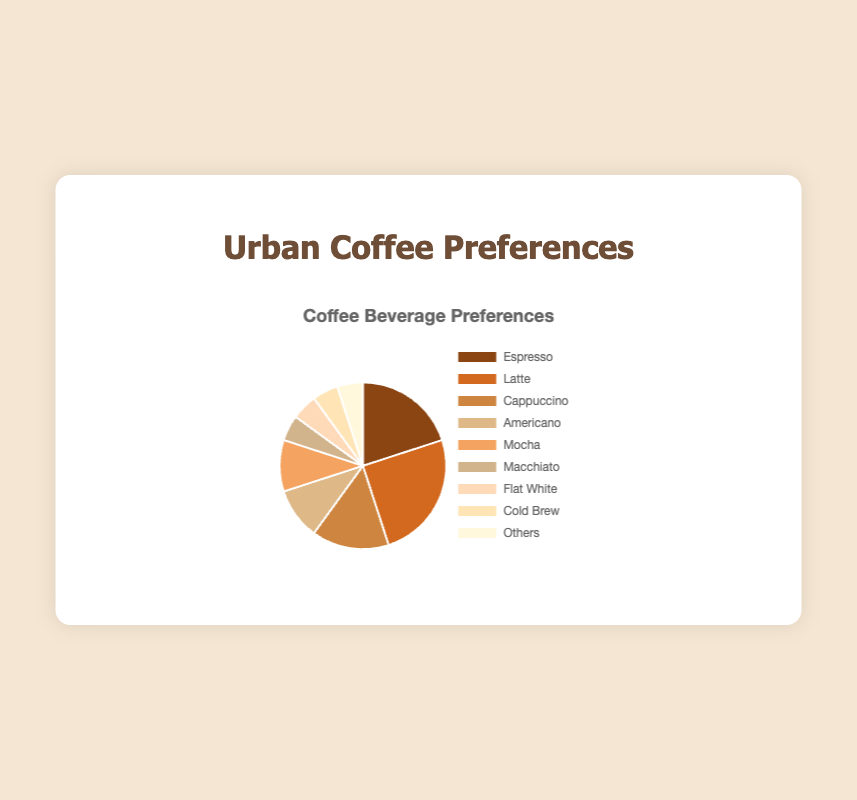1. What coffee beverage has the highest preference among urban consumers? To determine the coffee beverage with the highest preference, look for the slice of the pie chart with the largest percentage. The beverage with a 25% share is the one.
Answer: Latte 2. Which two coffee types have the same percentage preference? Look at the pie chart and identify the coffee types that have equal-sized sections representing the same percentage. Both Americano and Mocha have 10%
Answer: Americano and Mocha 3. What is the total percentage of consumers preferring Americano, Mocha, and Macchiato? Add the percentages of Americano (10%), Mocha (10%), and Macchiato (5%) to get the total. 10% + 10% + 5% = 25%
Answer: 25% 4. Which coffee type has a higher preference: Espresso or Cappuccino? Compare the percentage slices for Espresso (20%) and Cappuccino (15%) in the pie chart. Espresso has a higher percentage.
Answer: Espresso 5. How much more popular is Latte compared to Flat White? Find the percentage difference by subtracting the percentage of Flat White (5%) from the percentage of Latte (25%). 25% - 5% = 20%
Answer: 20% 6. What percentage of consumers prefer either Flat White or Cold Brew? Add the percentages of Flat White (5%) and Cold Brew (5%) together. 5% + 5% = 10%
Answer: 10% 7. Is the preference for Macchiato equal to or greater than the preference for Cold Brew? Compare the percentages of Macchiato (5%) and Cold Brew (5%). Both have the same percentage.
Answer: Equal 8. What is the combined percentage of consumers who prefer beverages other than Espresso, Latte, and Cappuccino? Subtract the percentages of Espresso (20%), Latte (25%), and Cappuccino (15%) from 100%. 100% - (20% + 25% + 15%) = 40%
Answer: 40% 9. What is the median value of coffee preference percentages? List the percentages in ascending order: 5%, 5%, 5%, 5%, 10%, 10%, 15%, 20%, 25%. The middle value in the sorted list is the median, which is 10%.
Answer: 10% 10. How much less popular is Americano compared to Latte? Subtract the percentage of Americano (10%) from the percentage of Latte (25%). 25% - 10% = 15%
Answer: 15% 